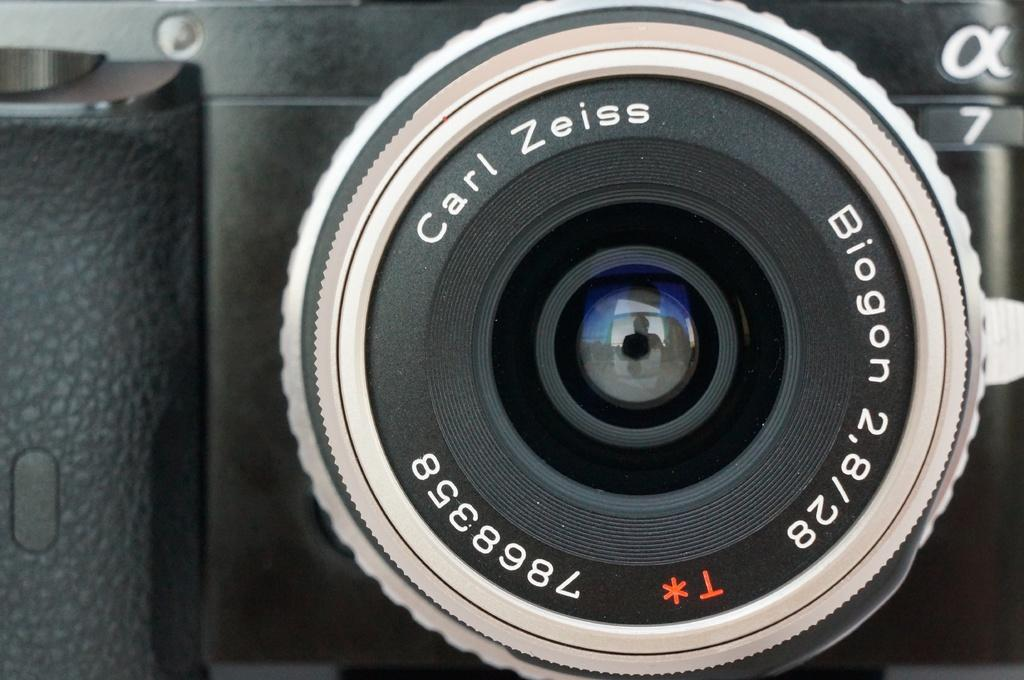What is the main subject of the picture? The main subject of the picture is a camera. Where is the camera lens located in the picture? The camera lens is in the center of the picture. What type of credit can be seen on the border of the image? There is no credit or border present in the image; it is a picture of a camera with the lens in the center. 